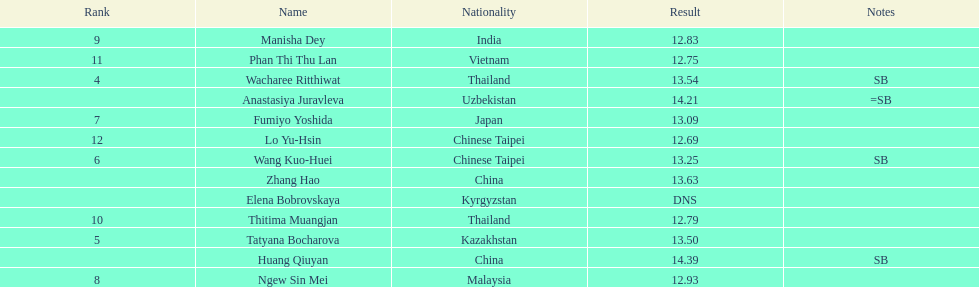How long was manisha dey's jump? 12.83. 